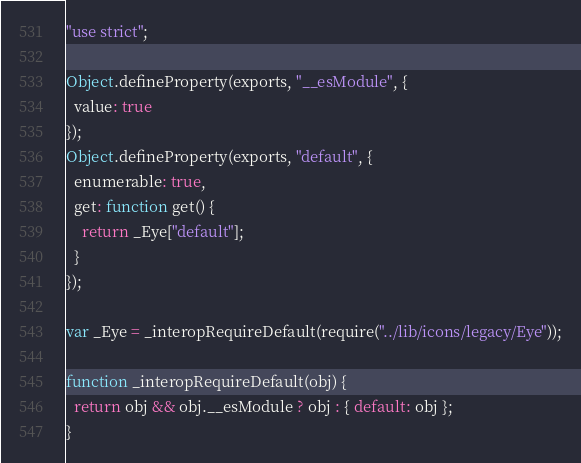<code> <loc_0><loc_0><loc_500><loc_500><_JavaScript_>"use strict";

Object.defineProperty(exports, "__esModule", {
  value: true
});
Object.defineProperty(exports, "default", {
  enumerable: true,
  get: function get() {
    return _Eye["default"];
  }
});

var _Eye = _interopRequireDefault(require("../lib/icons/legacy/Eye"));

function _interopRequireDefault(obj) {
  return obj && obj.__esModule ? obj : { default: obj };
}
</code> 